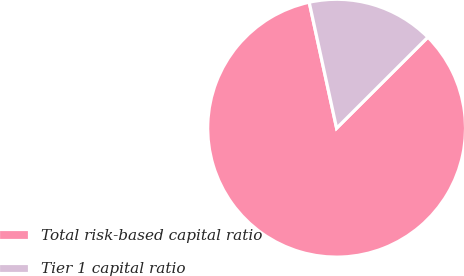Convert chart. <chart><loc_0><loc_0><loc_500><loc_500><pie_chart><fcel>Total risk-based capital ratio<fcel>Tier 1 capital ratio<nl><fcel>84.07%<fcel>15.93%<nl></chart> 